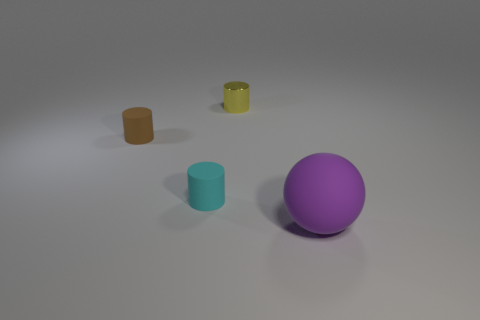Add 4 large brown things. How many objects exist? 8 Subtract all cylinders. How many objects are left? 1 Subtract all small green metallic balls. Subtract all purple matte things. How many objects are left? 3 Add 4 tiny yellow shiny cylinders. How many tiny yellow shiny cylinders are left? 5 Add 3 big things. How many big things exist? 4 Subtract 0 red cubes. How many objects are left? 4 